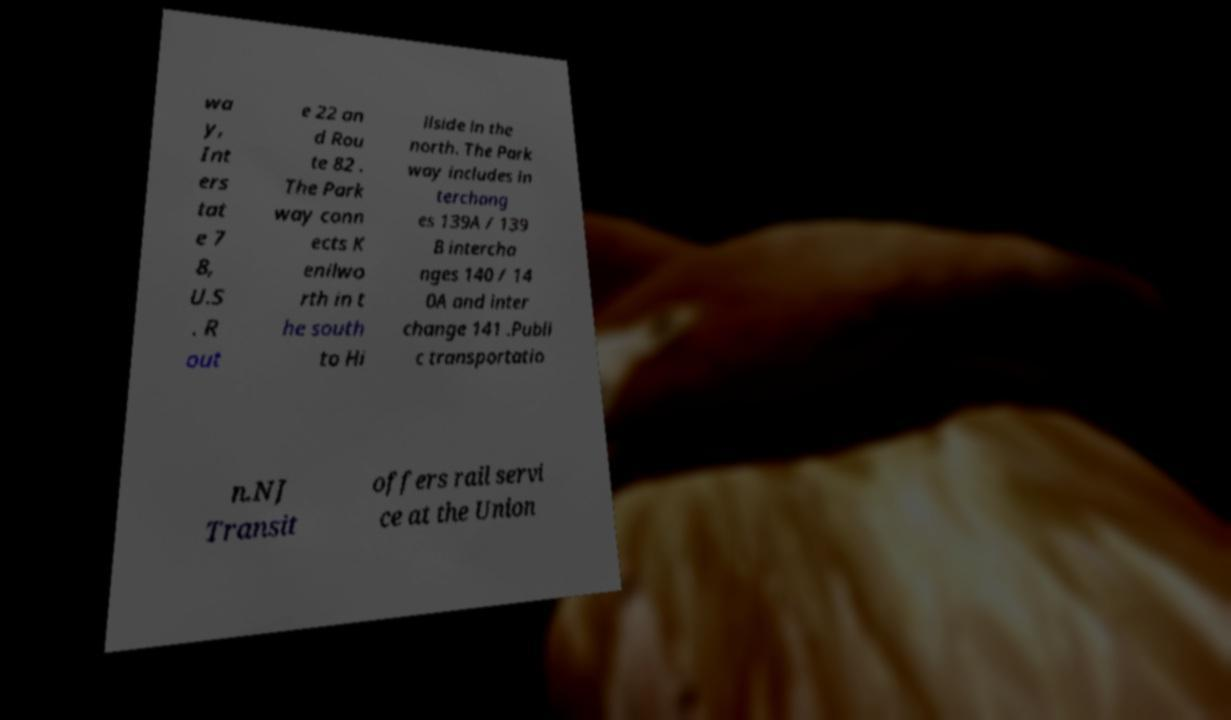There's text embedded in this image that I need extracted. Can you transcribe it verbatim? wa y, Int ers tat e 7 8, U.S . R out e 22 an d Rou te 82 . The Park way conn ects K enilwo rth in t he south to Hi llside in the north. The Park way includes in terchang es 139A / 139 B intercha nges 140 / 14 0A and inter change 141 .Publi c transportatio n.NJ Transit offers rail servi ce at the Union 